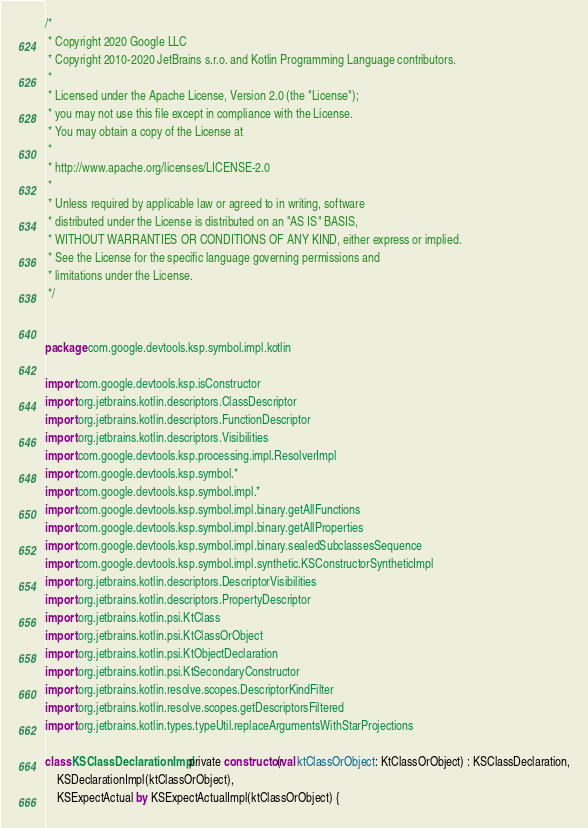<code> <loc_0><loc_0><loc_500><loc_500><_Kotlin_>/*
 * Copyright 2020 Google LLC
 * Copyright 2010-2020 JetBrains s.r.o. and Kotlin Programming Language contributors.
 *
 * Licensed under the Apache License, Version 2.0 (the "License");
 * you may not use this file except in compliance with the License.
 * You may obtain a copy of the License at
 *
 * http://www.apache.org/licenses/LICENSE-2.0
 *
 * Unless required by applicable law or agreed to in writing, software
 * distributed under the License is distributed on an "AS IS" BASIS,
 * WITHOUT WARRANTIES OR CONDITIONS OF ANY KIND, either express or implied.
 * See the License for the specific language governing permissions and
 * limitations under the License.
 */


package com.google.devtools.ksp.symbol.impl.kotlin

import com.google.devtools.ksp.isConstructor
import org.jetbrains.kotlin.descriptors.ClassDescriptor
import org.jetbrains.kotlin.descriptors.FunctionDescriptor
import org.jetbrains.kotlin.descriptors.Visibilities
import com.google.devtools.ksp.processing.impl.ResolverImpl
import com.google.devtools.ksp.symbol.*
import com.google.devtools.ksp.symbol.impl.*
import com.google.devtools.ksp.symbol.impl.binary.getAllFunctions
import com.google.devtools.ksp.symbol.impl.binary.getAllProperties
import com.google.devtools.ksp.symbol.impl.binary.sealedSubclassesSequence
import com.google.devtools.ksp.symbol.impl.synthetic.KSConstructorSyntheticImpl
import org.jetbrains.kotlin.descriptors.DescriptorVisibilities
import org.jetbrains.kotlin.descriptors.PropertyDescriptor
import org.jetbrains.kotlin.psi.KtClass
import org.jetbrains.kotlin.psi.KtClassOrObject
import org.jetbrains.kotlin.psi.KtObjectDeclaration
import org.jetbrains.kotlin.psi.KtSecondaryConstructor
import org.jetbrains.kotlin.resolve.scopes.DescriptorKindFilter
import org.jetbrains.kotlin.resolve.scopes.getDescriptorsFiltered
import org.jetbrains.kotlin.types.typeUtil.replaceArgumentsWithStarProjections

class KSClassDeclarationImpl private constructor(val ktClassOrObject: KtClassOrObject) : KSClassDeclaration,
    KSDeclarationImpl(ktClassOrObject),
    KSExpectActual by KSExpectActualImpl(ktClassOrObject) {</code> 